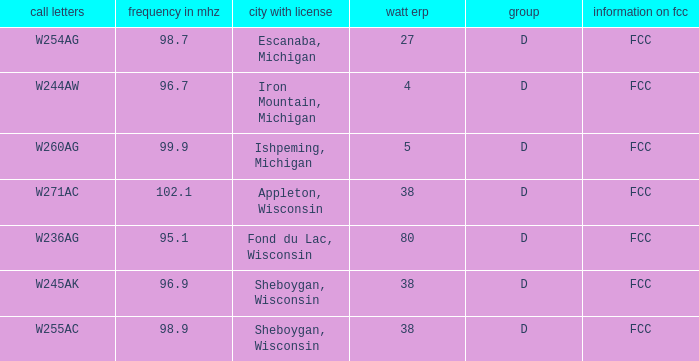What was the class for Appleton, Wisconsin? D. 